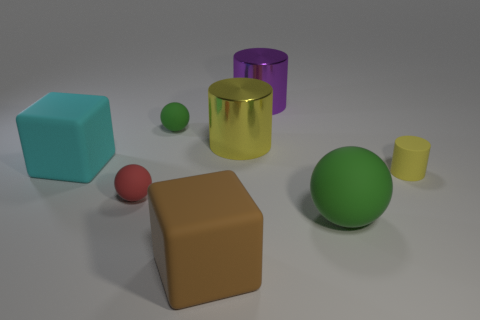What number of red matte spheres have the same size as the cyan matte block?
Offer a terse response. 0. The large object that is behind the big brown rubber block and in front of the small red matte thing is made of what material?
Give a very brief answer. Rubber. What is the material of the red sphere that is the same size as the yellow rubber cylinder?
Your response must be concise. Rubber. How big is the green rubber thing that is to the left of the green thing that is in front of the green rubber thing that is on the left side of the brown thing?
Give a very brief answer. Small. What is the size of the yellow cylinder that is made of the same material as the brown object?
Offer a very short reply. Small. Do the yellow metal cylinder and the block that is behind the large green matte ball have the same size?
Make the answer very short. Yes. What is the shape of the big rubber object that is left of the tiny red object?
Ensure brevity in your answer.  Cube. Is there a large cyan block that is to the right of the cylinder that is behind the green matte ball behind the cyan matte object?
Your response must be concise. No. What is the material of the big yellow object that is the same shape as the purple object?
Keep it short and to the point. Metal. Are there any other things that are made of the same material as the large yellow thing?
Provide a succinct answer. Yes. 